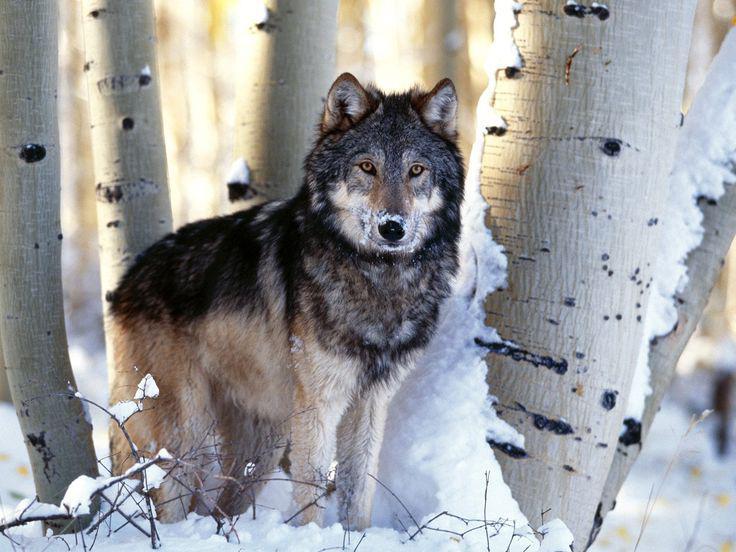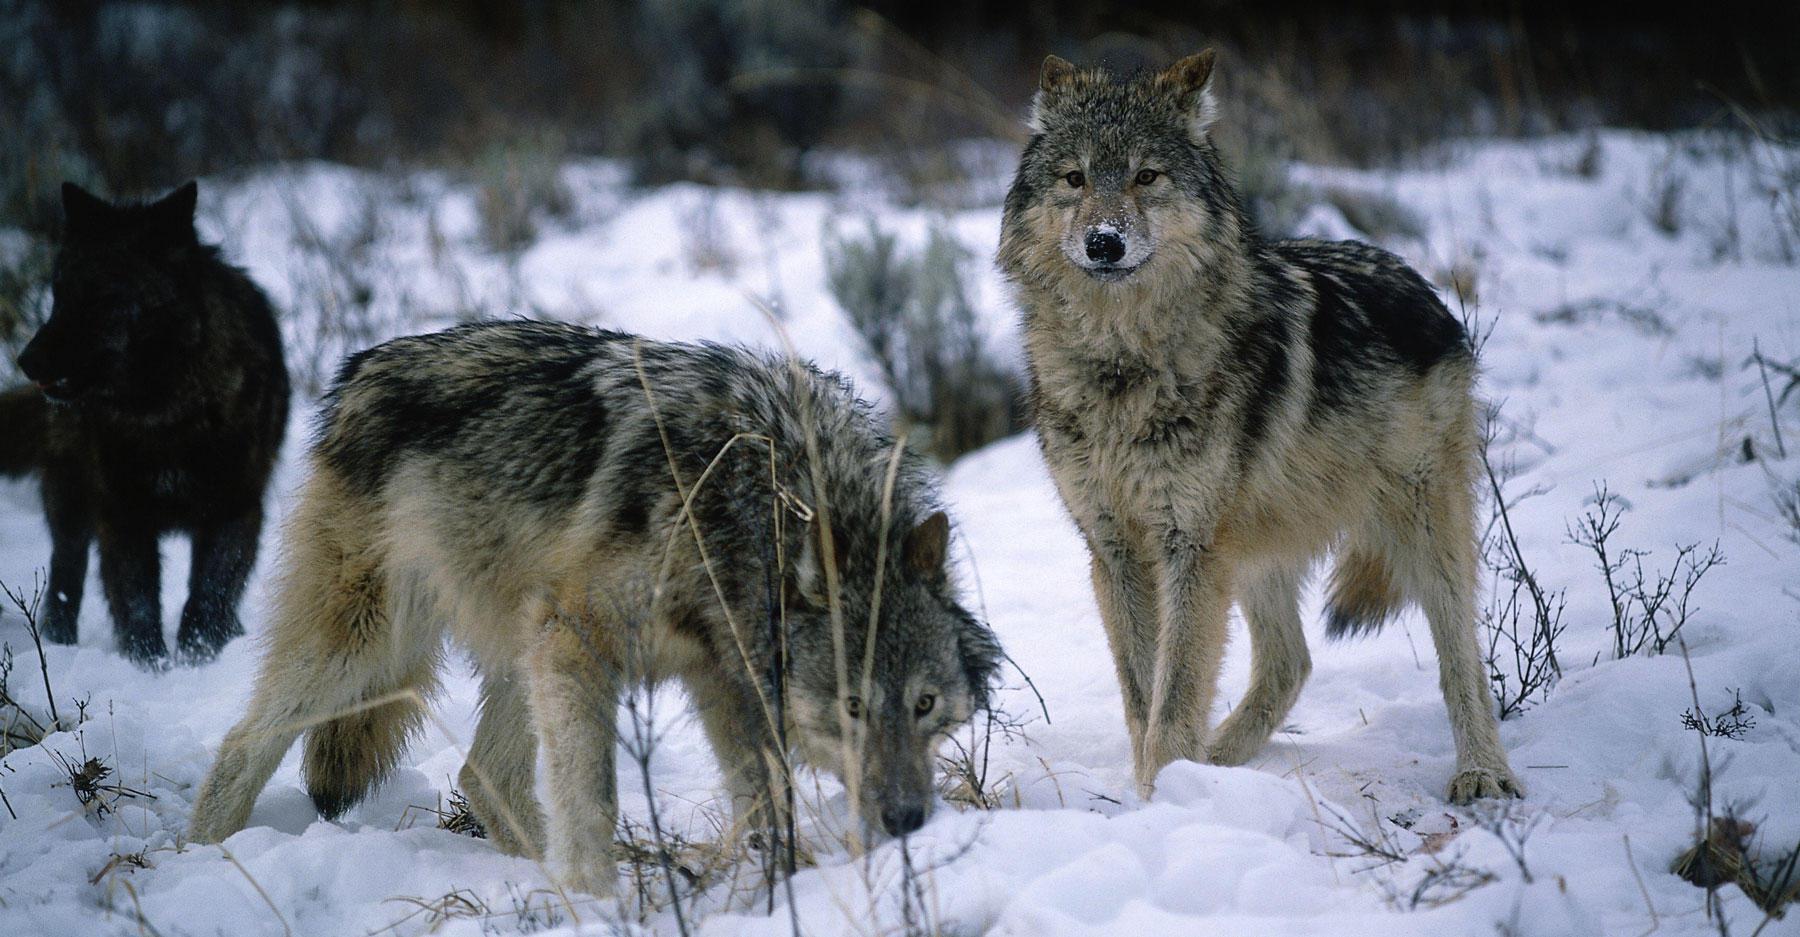The first image is the image on the left, the second image is the image on the right. Considering the images on both sides, is "There are at least six wolves." valid? Answer yes or no. No. The first image is the image on the left, the second image is the image on the right. Analyze the images presented: Is the assertion "there are 4 wolves in the image pair" valid? Answer yes or no. Yes. 